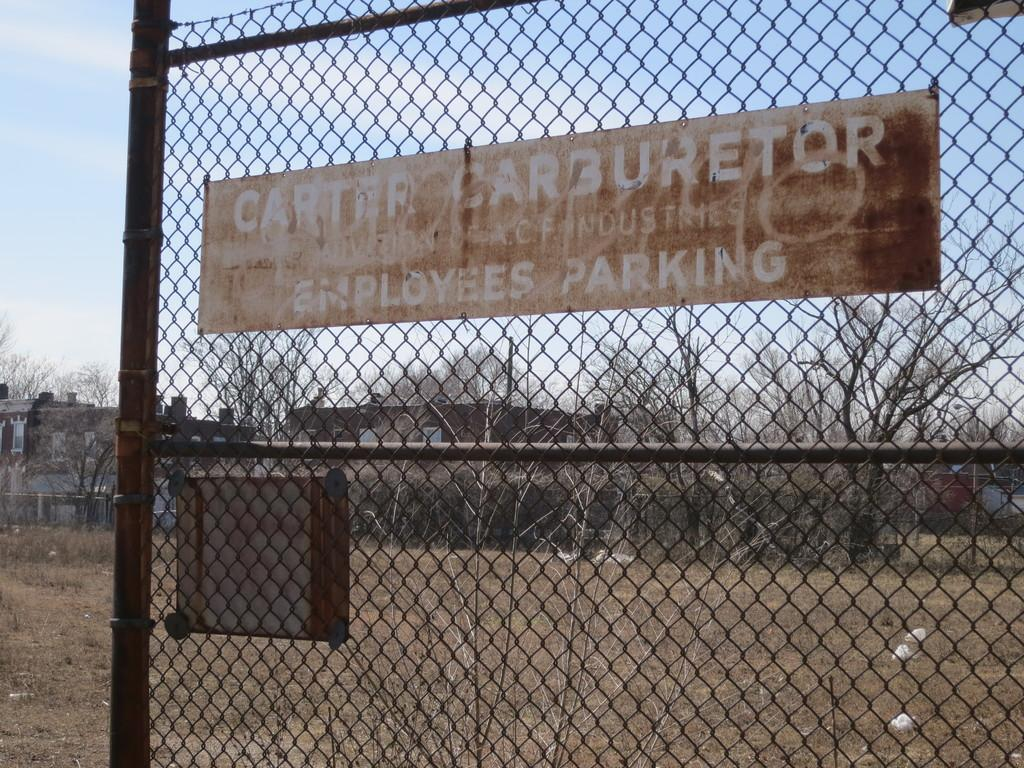What type of structure can be seen in the image? There is a fence in the image. What is attached to the fence? There is a board on the fence. What can be seen behind the fence? Trees and buildings are visible behind the fence. What part of the natural environment is visible in the image? The sky is visible in the image. How many health questions are being asked in the image? There are no health questions present in the image; it features a fence with a board and a background of trees, buildings, and the sky. Can you tell me how many cats are sitting on the fence in the image? There are no cats present in the image; it features a fence with a board and a background of trees, buildings, and the sky. 